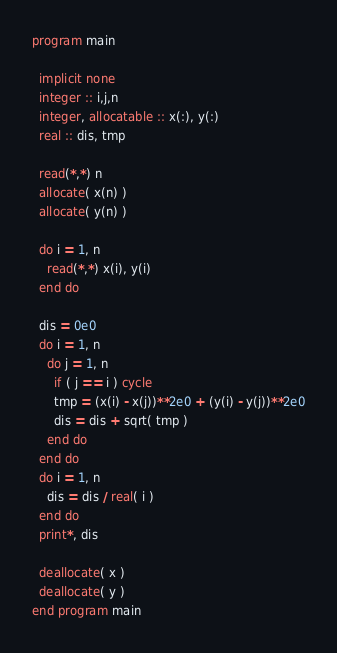<code> <loc_0><loc_0><loc_500><loc_500><_FORTRAN_>program main

  implicit none
  integer :: i,j,n 
  integer, allocatable :: x(:), y(:)
  real :: dis, tmp
  
  read(*,*) n 
  allocate( x(n) )
  allocate( y(n) )

  do i = 1, n
    read(*,*) x(i), y(i) 
  end do
  
  dis = 0e0
  do i = 1, n
    do j = 1, n
      if ( j == i ) cycle
      tmp = (x(i) - x(j))**2e0 + (y(i) - y(j))**2e0
      dis = dis + sqrt( tmp ) 
    end do
  end do
  do i = 1, n
    dis = dis / real( i )
  end do
  print*, dis

  deallocate( x )
  deallocate( y )
end program main
</code> 